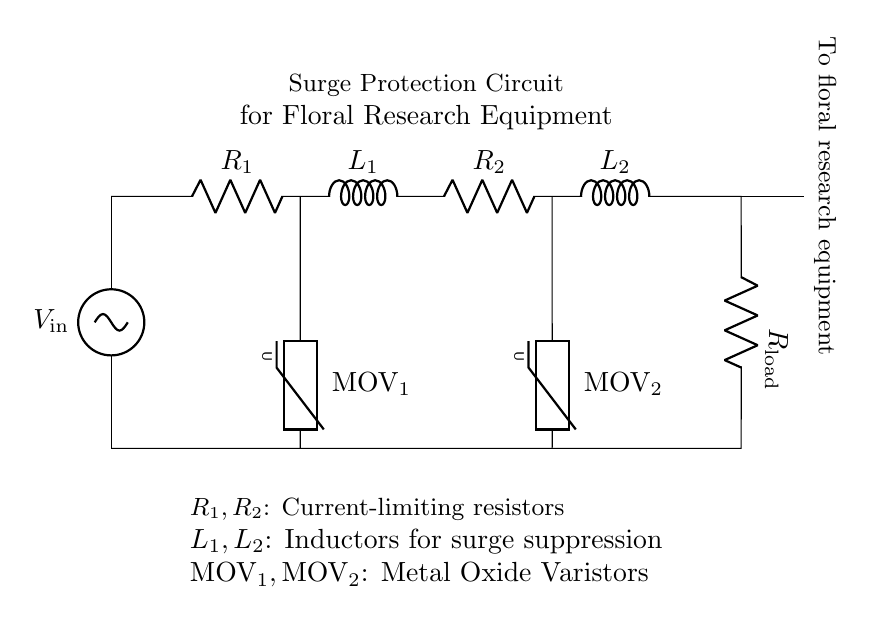What are the components used in this surge protection circuit? The circuit diagram includes resistors, inductors, and Metal Oxide Varistors. Specifically, the components are two resistors (R1 and R2), two inductors (L1 and L2), and two varistors (MOV1 and MOV2).
Answer: resistors, inductors, varistors What is the function of R1 and R2 in this circuit? R1 and R2 are current-limiting resistors that protect the sensitive equipment by limiting the current flow during surges, thus preventing potential damage. They help maintain safe operating conditions for the connected load.
Answer: current-limiting What is the role of inductors L1 and L2? Inductors L1 and L2 are used for surge suppression. They store energy from voltage spikes and help mitigate the effects of transient surges that can occur during tropical storms, ensuring the equipment remains protected.
Answer: surge suppression How many varistors are present in the circuit? The circuit diagram shows two varistors, MOV1 and MOV2. These components are part of the surge protection strategy, acting to clamp voltage spikes to safe levels.
Answer: two What happens during a voltage surge event in this circuit? During a voltage surge, the varistors (MOV1 and MOV2) conduct, diverting excess current away from the load. The inductors (L1 and L2) provide additional filtering to smooth out transient spikes, while the resistors (R1 and R2) limit the overall current, protecting the equipment.
Answer: varistors conduct, inductors filter, resistors limit current How is the floral research equipment connected in this circuit? The floral research equipment is connected at the output terminal, labeled as "To floral research equipment." This point is where the protected voltage is supplied to the equipment, ensuring it only receives safe levels.
Answer: connected at the output terminal What type of circuit configuration is used for the resistors and inductors in this diagram? The resistors and inductors are arranged in series. This means the current flows sequentially through each component, which allows the circuit to function effectively for surge protection.
Answer: series configuration 